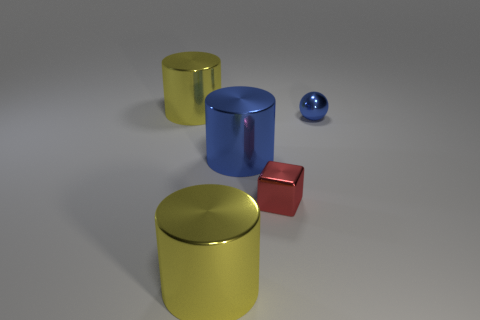Subtract all yellow cylinders. How many cylinders are left? 1 Subtract all green blocks. How many yellow cylinders are left? 2 Subtract 1 cylinders. How many cylinders are left? 2 Add 5 red blocks. How many objects exist? 10 Subtract all purple cylinders. Subtract all green spheres. How many cylinders are left? 3 Subtract all cylinders. How many objects are left? 2 Subtract all small shiny blocks. Subtract all small red objects. How many objects are left? 3 Add 1 blue shiny cylinders. How many blue shiny cylinders are left? 2 Add 4 cyan matte objects. How many cyan matte objects exist? 4 Subtract 1 yellow cylinders. How many objects are left? 4 